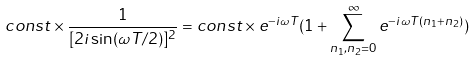Convert formula to latex. <formula><loc_0><loc_0><loc_500><loc_500>c o n s t \times \frac { 1 } { [ 2 i \sin ( \omega T / 2 ) ] ^ { 2 } } = c o n s t \times e ^ { - i \omega T } ( 1 + \sum _ { n _ { 1 } , n _ { 2 } = 0 } ^ { \infty } e ^ { - i \omega T ( n _ { 1 } + n _ { 2 } ) } )</formula> 